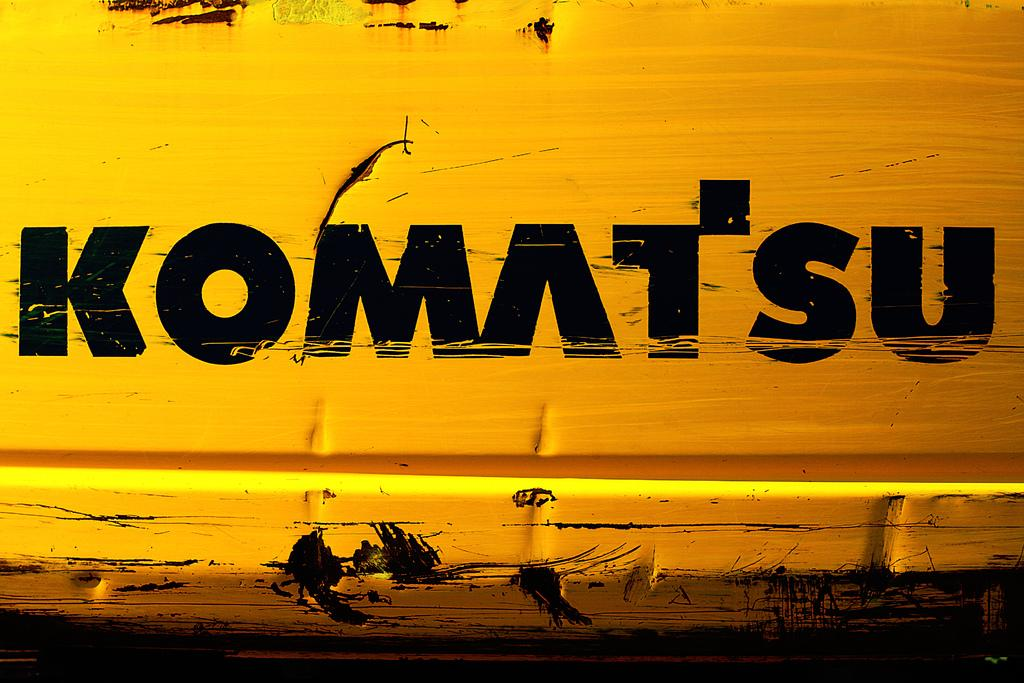Provide a one-sentence caption for the provided image. White surface with the word "Komatsu" in black words. 